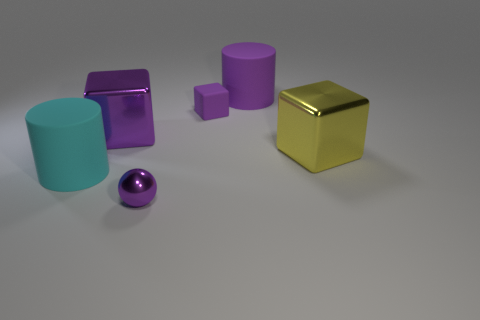The big purple object that is made of the same material as the big cyan cylinder is what shape?
Provide a succinct answer. Cylinder. There is a big purple object that is left of the large rubber cylinder behind the large yellow metal object; how many purple rubber blocks are left of it?
Provide a short and direct response. 0. There is a big object that is both behind the large yellow metal block and to the left of the purple ball; what is its shape?
Provide a succinct answer. Cube. Are there fewer purple metallic things that are left of the cyan cylinder than tiny objects?
Provide a succinct answer. Yes. What number of small objects are either gray matte cylinders or yellow blocks?
Give a very brief answer. 0. What size is the purple matte cube?
Provide a succinct answer. Small. Are there any other things that have the same material as the large yellow cube?
Make the answer very short. Yes. What number of large purple things are right of the small purple shiny object?
Offer a terse response. 1. There is another object that is the same shape as the large cyan rubber thing; what size is it?
Provide a short and direct response. Large. There is a rubber object that is on the right side of the small sphere and in front of the purple rubber cylinder; what size is it?
Your response must be concise. Small. 